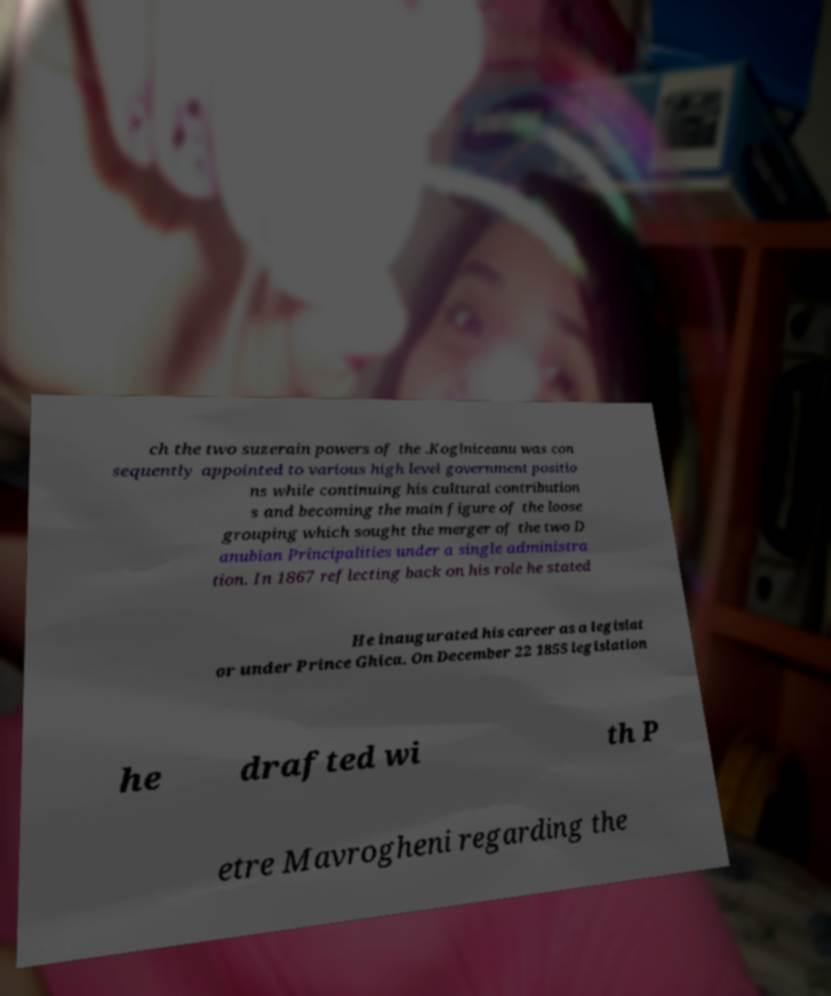Please identify and transcribe the text found in this image. ch the two suzerain powers of the .Koglniceanu was con sequently appointed to various high level government positio ns while continuing his cultural contribution s and becoming the main figure of the loose grouping which sought the merger of the two D anubian Principalities under a single administra tion. In 1867 reflecting back on his role he stated He inaugurated his career as a legislat or under Prince Ghica. On December 22 1855 legislation he drafted wi th P etre Mavrogheni regarding the 